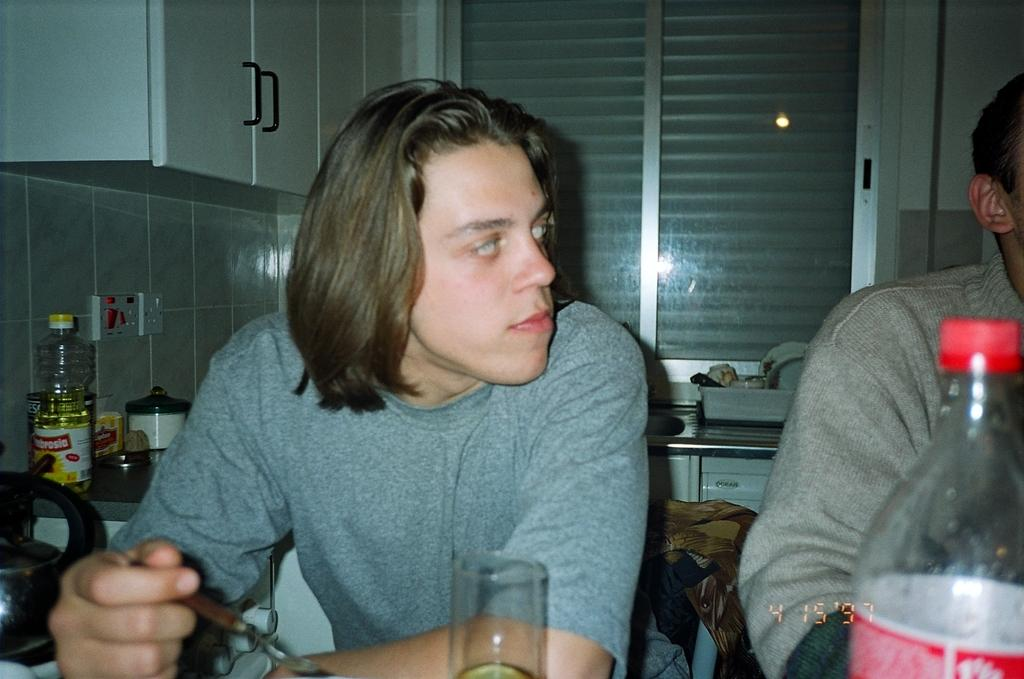Who or what is present in the image? There is a person in the image. What can be seen on the countertop in the image? There is a bottle and vessels on the countertop. What type of line can be seen on the chalkboard in the image? There is no chalkboard or line present in the image. What kind of animals can be seen on the farm in the image? There is no farm or animals present in the image. 